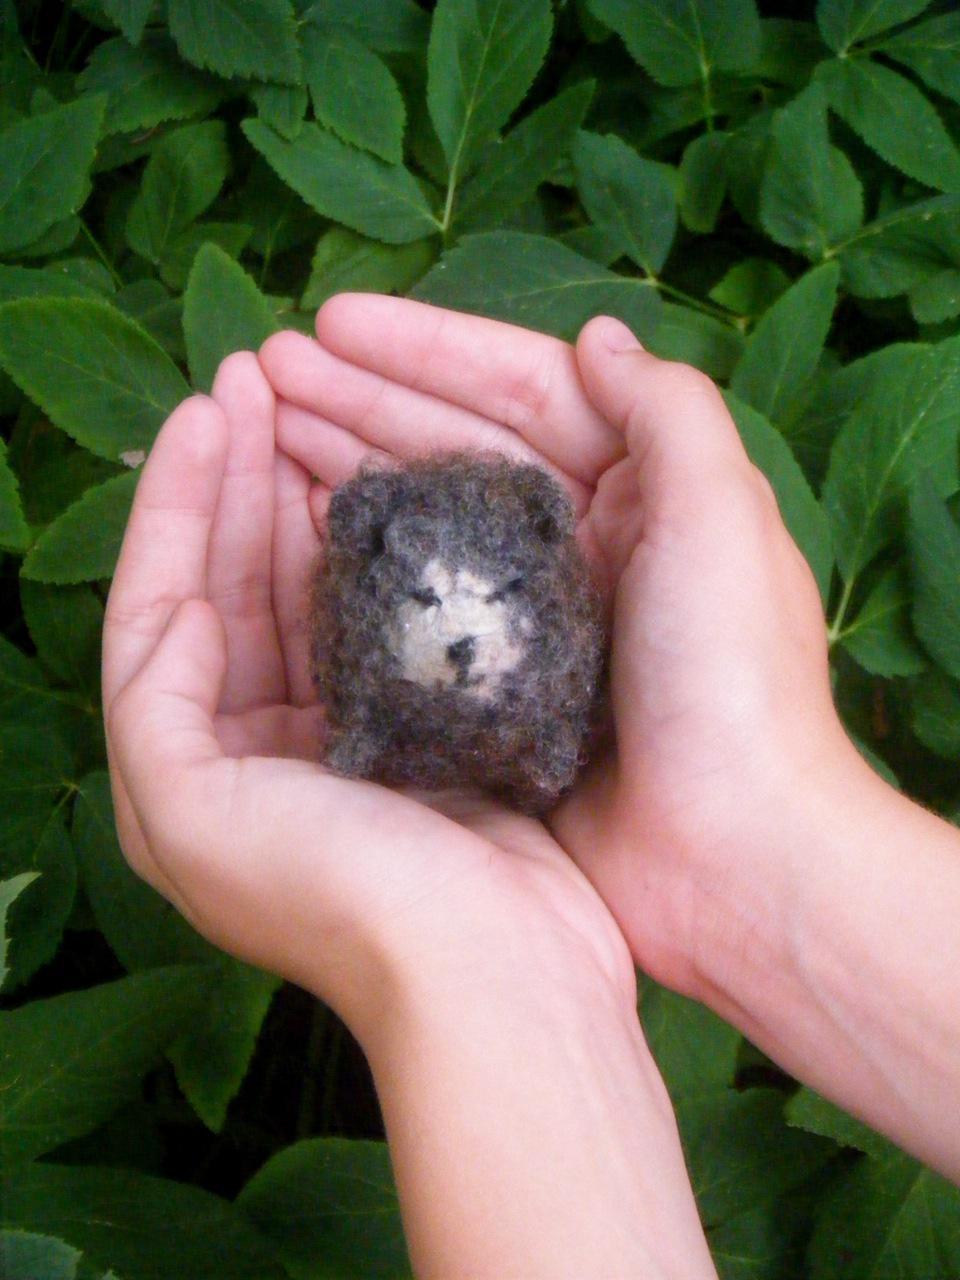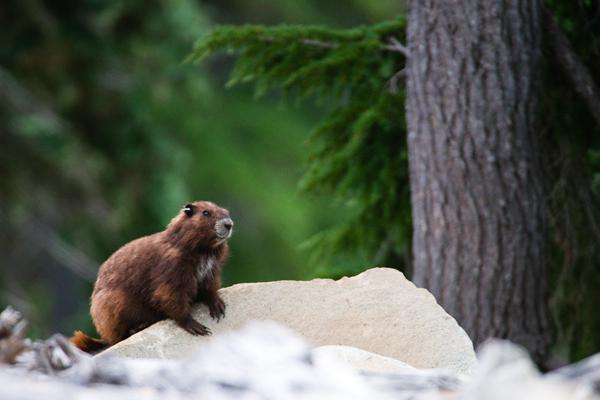The first image is the image on the left, the second image is the image on the right. Evaluate the accuracy of this statement regarding the images: "There are three marmots.". Is it true? Answer yes or no. No. The first image is the image on the left, the second image is the image on the right. Examine the images to the left and right. Is the description "One image shows two marmots posed face-to-face, and the other image shows one marmot on all fours on a rock." accurate? Answer yes or no. No. 